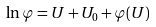<formula> <loc_0><loc_0><loc_500><loc_500>\ln \varphi = U + U _ { 0 } + \varphi ( U )</formula> 